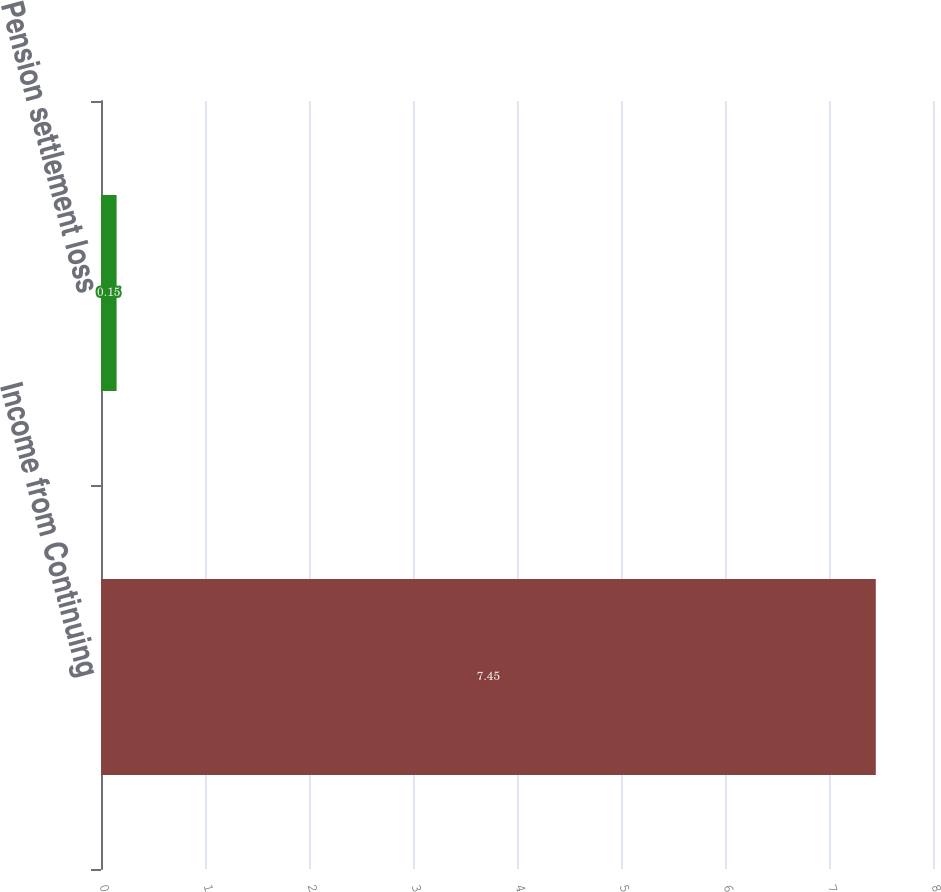Convert chart to OTSL. <chart><loc_0><loc_0><loc_500><loc_500><bar_chart><fcel>Income from Continuing<fcel>Pension settlement loss<nl><fcel>7.45<fcel>0.15<nl></chart> 